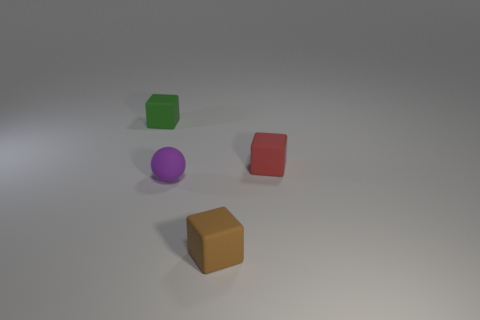Do the thing that is in front of the small purple matte thing and the small purple object that is to the left of the tiny red matte block have the same material?
Make the answer very short. Yes. There is a rubber thing that is right of the tiny rubber cube that is in front of the purple matte object; how many rubber things are in front of it?
Offer a terse response. 2. Is the color of the small object behind the red matte block the same as the small rubber cube in front of the tiny red thing?
Provide a short and direct response. No. Are there any other things that have the same color as the ball?
Your answer should be very brief. No. There is a rubber cube on the right side of the block that is in front of the small purple rubber thing; what is its color?
Your answer should be very brief. Red. Is there a large purple rubber cube?
Keep it short and to the point. No. The small thing that is both on the right side of the purple object and in front of the red matte thing is what color?
Keep it short and to the point. Brown. Is the size of the rubber object in front of the purple thing the same as the rubber object to the right of the small brown object?
Offer a terse response. Yes. What number of other things are there of the same size as the brown rubber cube?
Give a very brief answer. 3. How many brown rubber things are on the right side of the small thing on the right side of the tiny brown rubber block?
Make the answer very short. 0. 